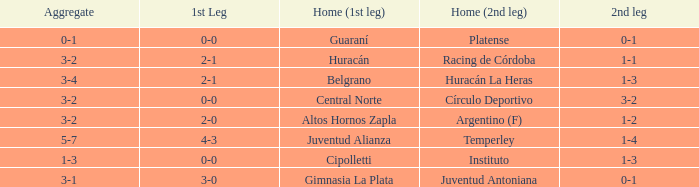Which team played their first leg at home with an aggregate score of 3-4? Belgrano. 